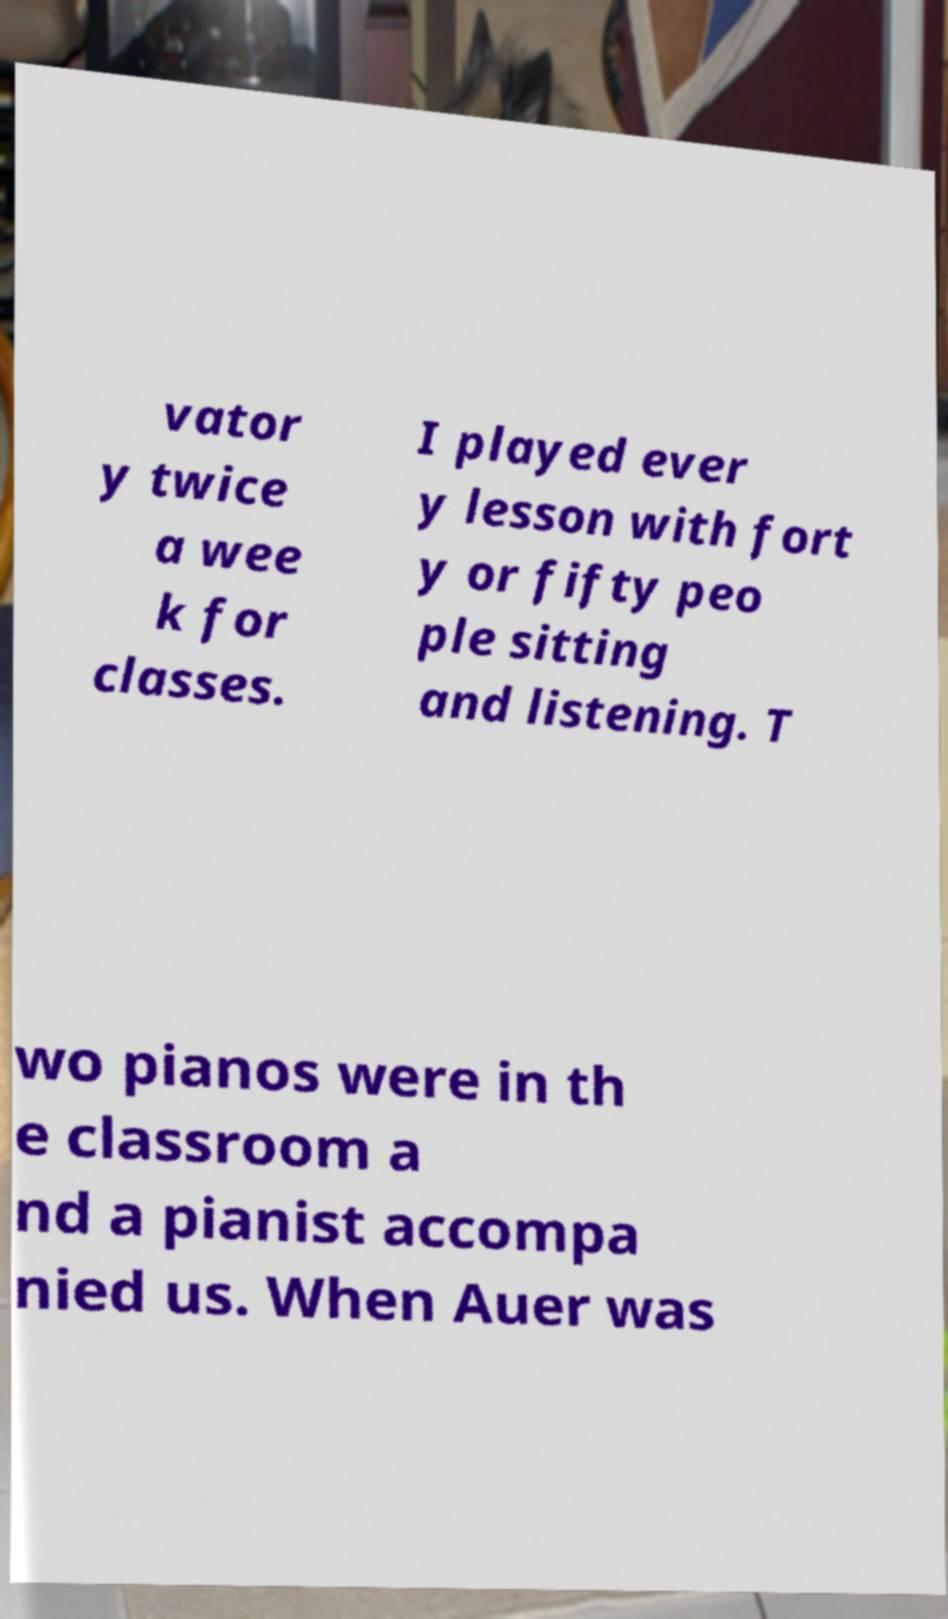Can you accurately transcribe the text from the provided image for me? vator y twice a wee k for classes. I played ever y lesson with fort y or fifty peo ple sitting and listening. T wo pianos were in th e classroom a nd a pianist accompa nied us. When Auer was 